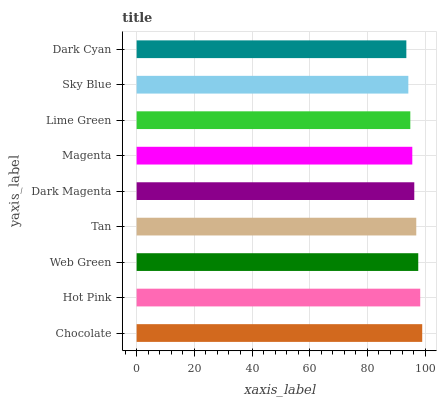Is Dark Cyan the minimum?
Answer yes or no. Yes. Is Chocolate the maximum?
Answer yes or no. Yes. Is Hot Pink the minimum?
Answer yes or no. No. Is Hot Pink the maximum?
Answer yes or no. No. Is Chocolate greater than Hot Pink?
Answer yes or no. Yes. Is Hot Pink less than Chocolate?
Answer yes or no. Yes. Is Hot Pink greater than Chocolate?
Answer yes or no. No. Is Chocolate less than Hot Pink?
Answer yes or no. No. Is Dark Magenta the high median?
Answer yes or no. Yes. Is Dark Magenta the low median?
Answer yes or no. Yes. Is Tan the high median?
Answer yes or no. No. Is Hot Pink the low median?
Answer yes or no. No. 